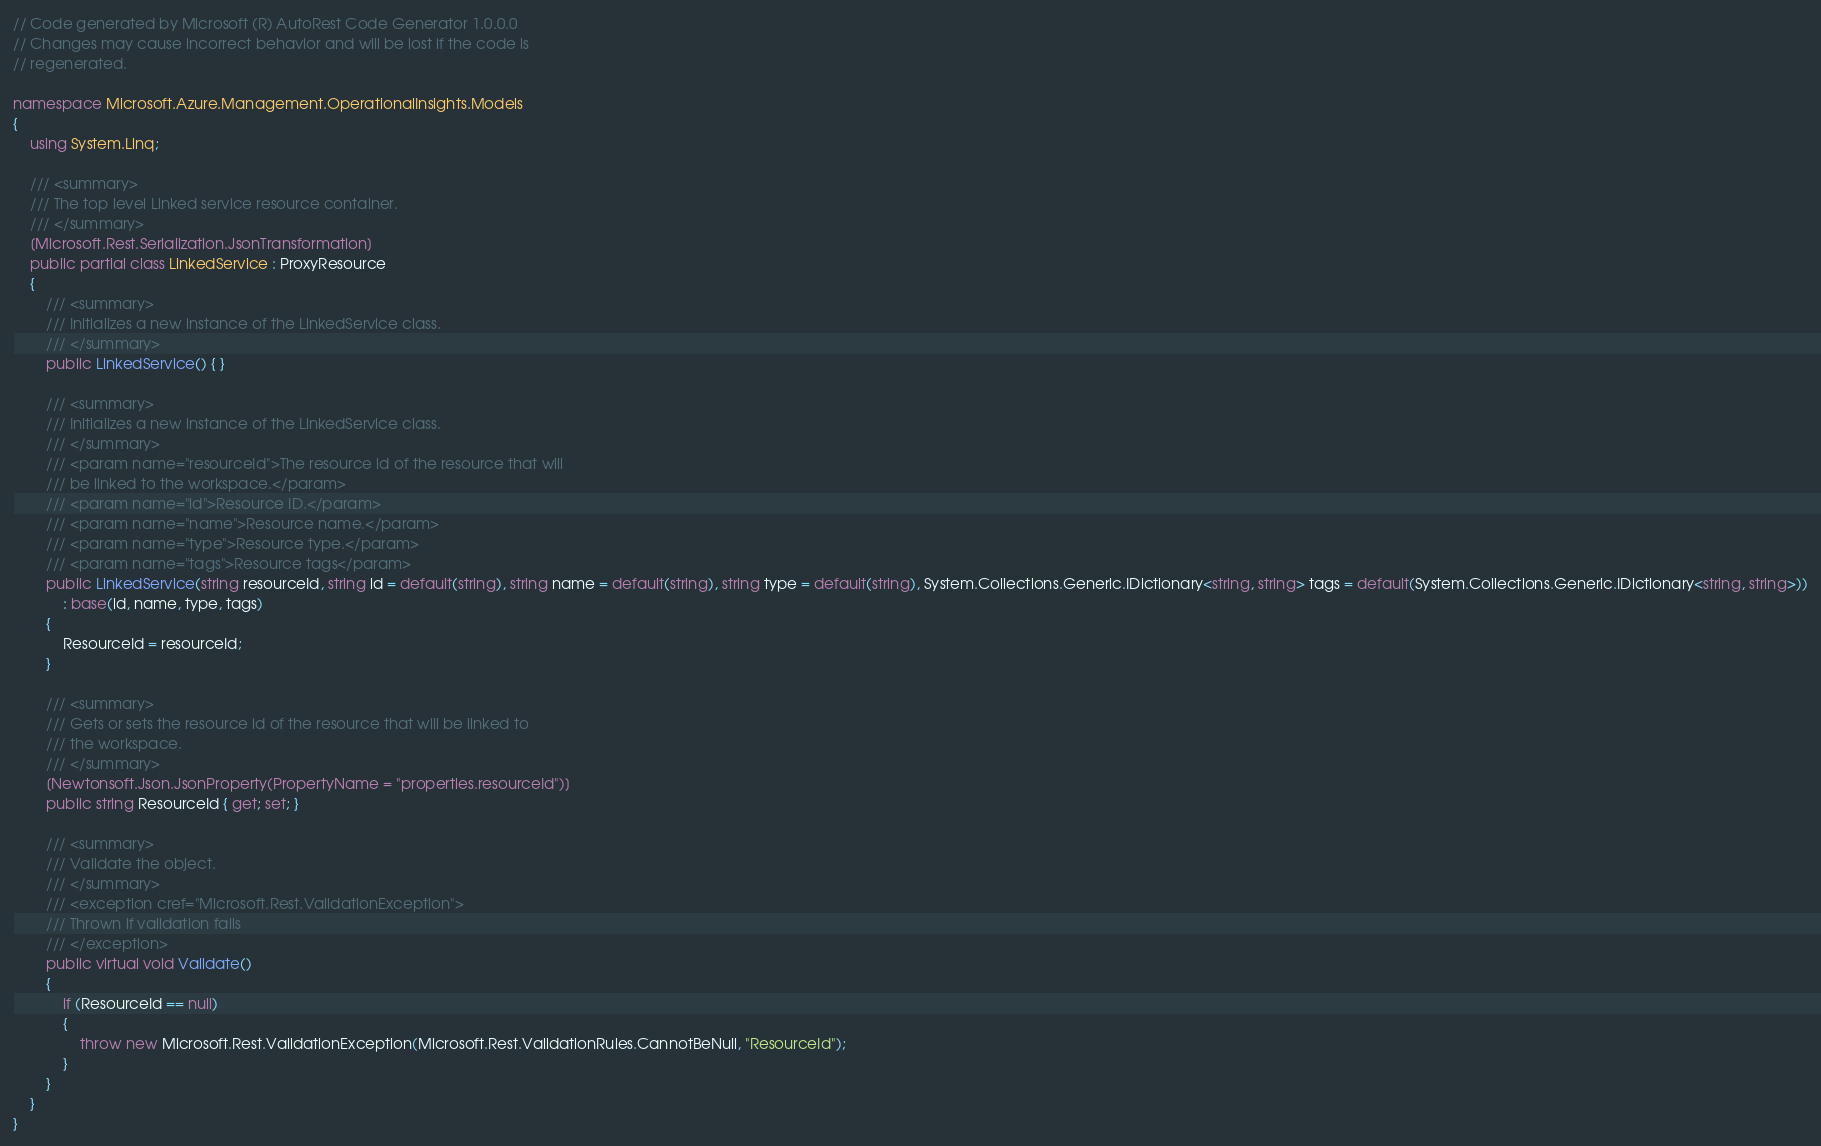<code> <loc_0><loc_0><loc_500><loc_500><_C#_>// Code generated by Microsoft (R) AutoRest Code Generator 1.0.0.0
// Changes may cause incorrect behavior and will be lost if the code is
// regenerated.

namespace Microsoft.Azure.Management.OperationalInsights.Models
{
    using System.Linq;

    /// <summary>
    /// The top level Linked service resource container.
    /// </summary>
    [Microsoft.Rest.Serialization.JsonTransformation]
    public partial class LinkedService : ProxyResource
    {
        /// <summary>
        /// Initializes a new instance of the LinkedService class.
        /// </summary>
        public LinkedService() { }

        /// <summary>
        /// Initializes a new instance of the LinkedService class.
        /// </summary>
        /// <param name="resourceId">The resource id of the resource that will
        /// be linked to the workspace.</param>
        /// <param name="id">Resource ID.</param>
        /// <param name="name">Resource name.</param>
        /// <param name="type">Resource type.</param>
        /// <param name="tags">Resource tags</param>
        public LinkedService(string resourceId, string id = default(string), string name = default(string), string type = default(string), System.Collections.Generic.IDictionary<string, string> tags = default(System.Collections.Generic.IDictionary<string, string>))
            : base(id, name, type, tags)
        {
            ResourceId = resourceId;
        }

        /// <summary>
        /// Gets or sets the resource id of the resource that will be linked to
        /// the workspace.
        /// </summary>
        [Newtonsoft.Json.JsonProperty(PropertyName = "properties.resourceId")]
        public string ResourceId { get; set; }

        /// <summary>
        /// Validate the object.
        /// </summary>
        /// <exception cref="Microsoft.Rest.ValidationException">
        /// Thrown if validation fails
        /// </exception>
        public virtual void Validate()
        {
            if (ResourceId == null)
            {
                throw new Microsoft.Rest.ValidationException(Microsoft.Rest.ValidationRules.CannotBeNull, "ResourceId");
            }
        }
    }
}
</code> 